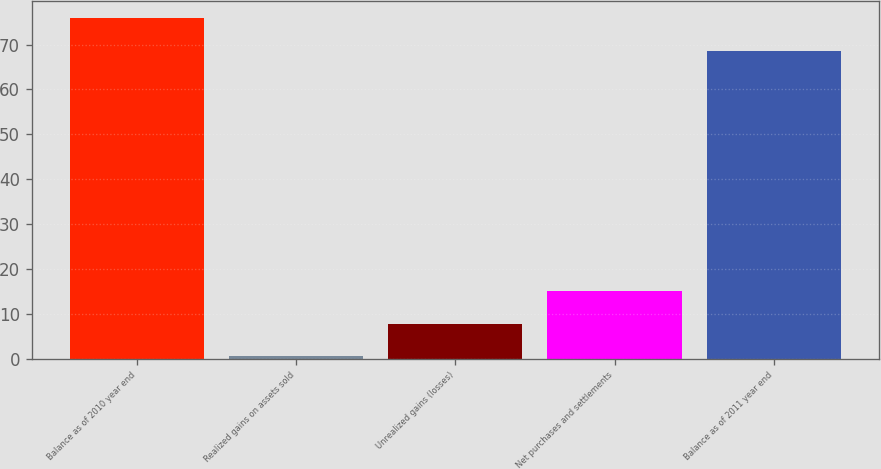Convert chart to OTSL. <chart><loc_0><loc_0><loc_500><loc_500><bar_chart><fcel>Balance as of 2010 year end<fcel>Realized gains on assets sold<fcel>Unrealized gains (losses)<fcel>Net purchases and settlements<fcel>Balance as of 2011 year end<nl><fcel>75.9<fcel>0.5<fcel>7.8<fcel>15.1<fcel>68.6<nl></chart> 